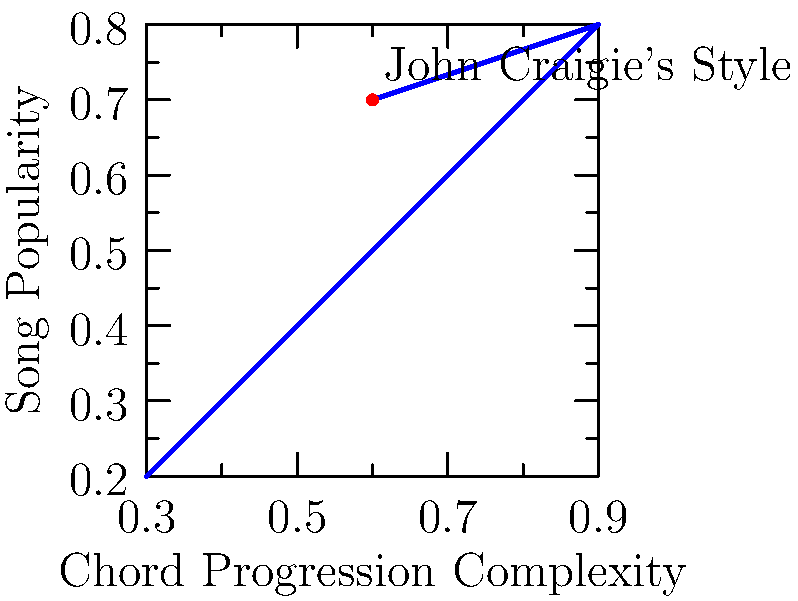Based on the chord progression complexity vs. song popularity graph for John Craigie's music style, what would be the predicted popularity for a new song with a chord progression complexity of 0.8? To answer this question, we need to follow these steps:

1. Observe the overall trend in the graph: As chord progression complexity increases, song popularity generally increases, but with some variation.

2. Locate the point on the x-axis corresponding to a chord progression complexity of 0.8.

3. Find the closest data points on either side of 0.8 on the x-axis:
   - (0.7, 0.6)
   - (0.9, 0.8)

4. Estimate the popularity for 0.8 complexity by interpolating between these two points:
   $$\text{Popularity} = 0.6 + (0.8 - 0.7) \times \frac{0.8 - 0.6}{0.9 - 0.7} \approx 0.7$$

5. Consider John Craigie's style point (0.6, 0.7) as a reference, which aligns with our estimate.

Therefore, for a new John Craigie song with a chord progression complexity of 0.8, we would predict a popularity of approximately 0.7.
Answer: 0.7 